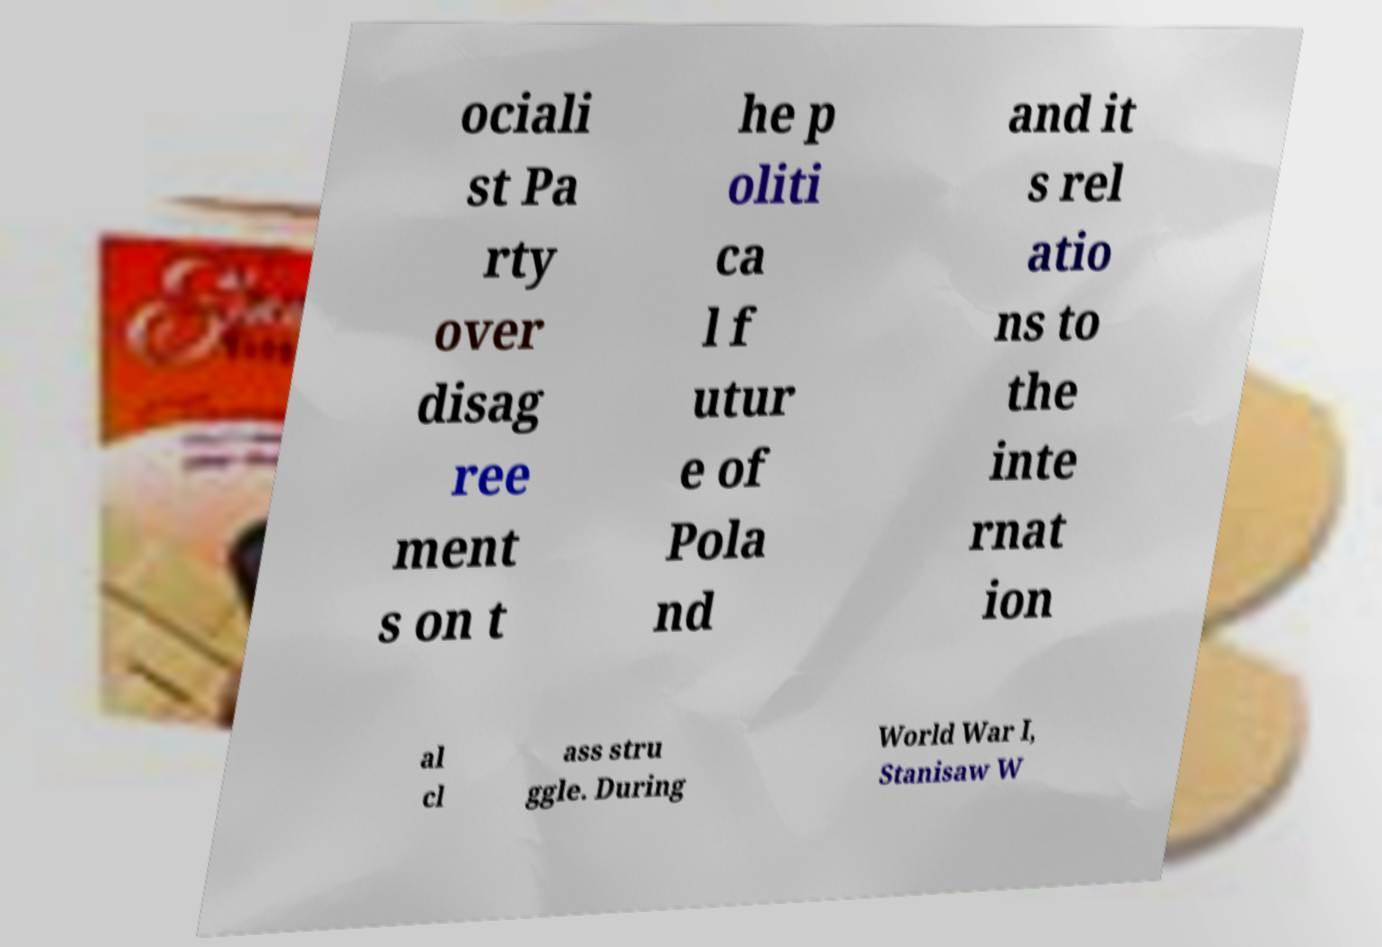Could you assist in decoding the text presented in this image and type it out clearly? ociali st Pa rty over disag ree ment s on t he p oliti ca l f utur e of Pola nd and it s rel atio ns to the inte rnat ion al cl ass stru ggle. During World War I, Stanisaw W 